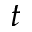<formula> <loc_0><loc_0><loc_500><loc_500>t</formula> 